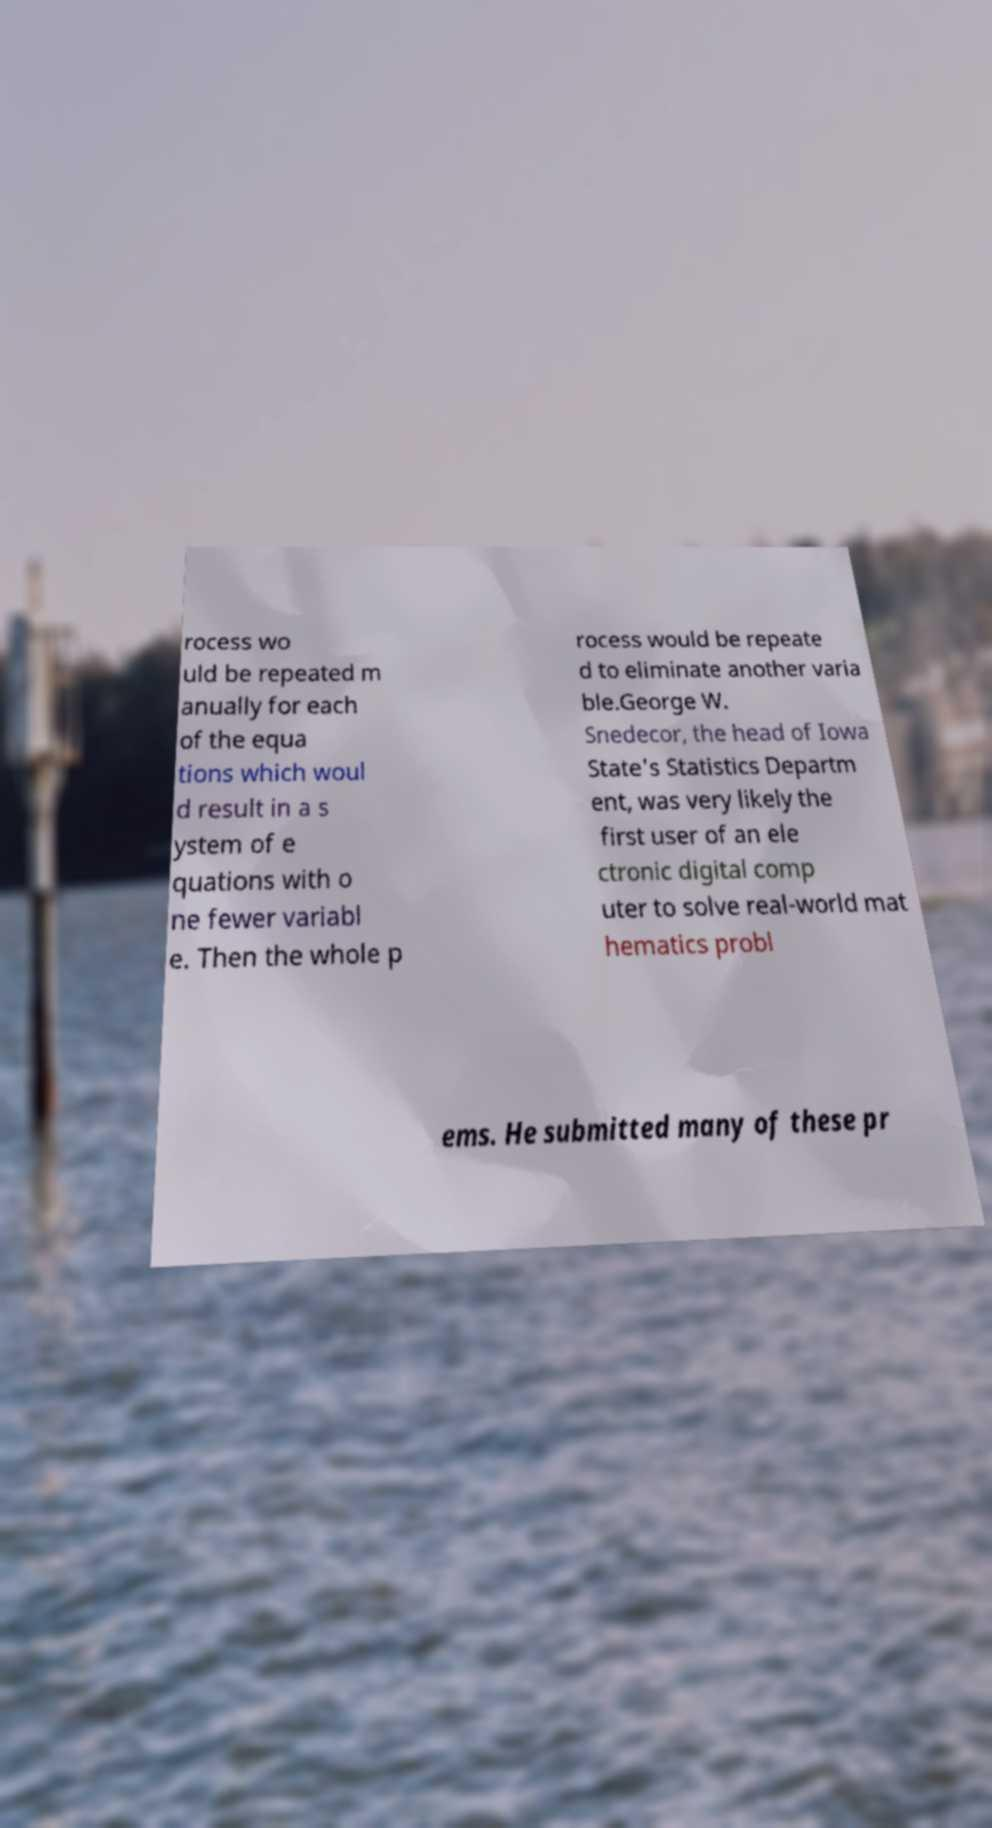For documentation purposes, I need the text within this image transcribed. Could you provide that? rocess wo uld be repeated m anually for each of the equa tions which woul d result in a s ystem of e quations with o ne fewer variabl e. Then the whole p rocess would be repeate d to eliminate another varia ble.George W. Snedecor, the head of Iowa State's Statistics Departm ent, was very likely the first user of an ele ctronic digital comp uter to solve real-world mat hematics probl ems. He submitted many of these pr 